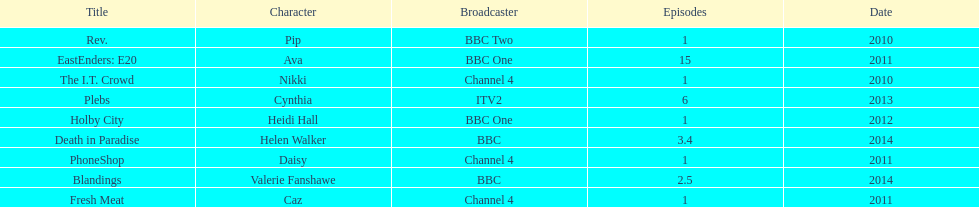Were there more than four episodes that featured cynthia? Yes. 